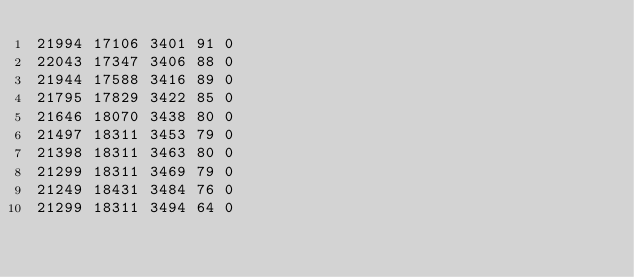<code> <loc_0><loc_0><loc_500><loc_500><_SML_>21994 17106 3401 91 0
22043 17347 3406 88 0
21944 17588 3416 89 0
21795 17829 3422 85 0
21646 18070 3438 80 0
21497 18311 3453 79 0
21398 18311 3463 80 0
21299 18311 3469 79 0
21249 18431 3484 76 0
21299 18311 3494 64 0</code> 